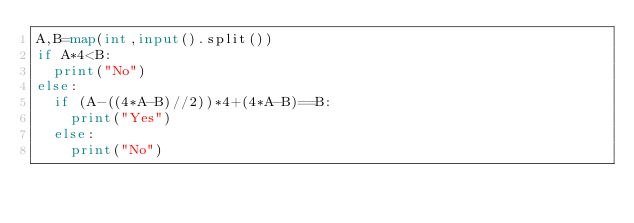Convert code to text. <code><loc_0><loc_0><loc_500><loc_500><_Python_>A,B=map(int,input().split())
if A*4<B:
  print("No")
else:
  if (A-((4*A-B)//2))*4+(4*A-B)==B:
    print("Yes")
  else:
    print("No")</code> 